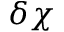Convert formula to latex. <formula><loc_0><loc_0><loc_500><loc_500>\delta \chi</formula> 